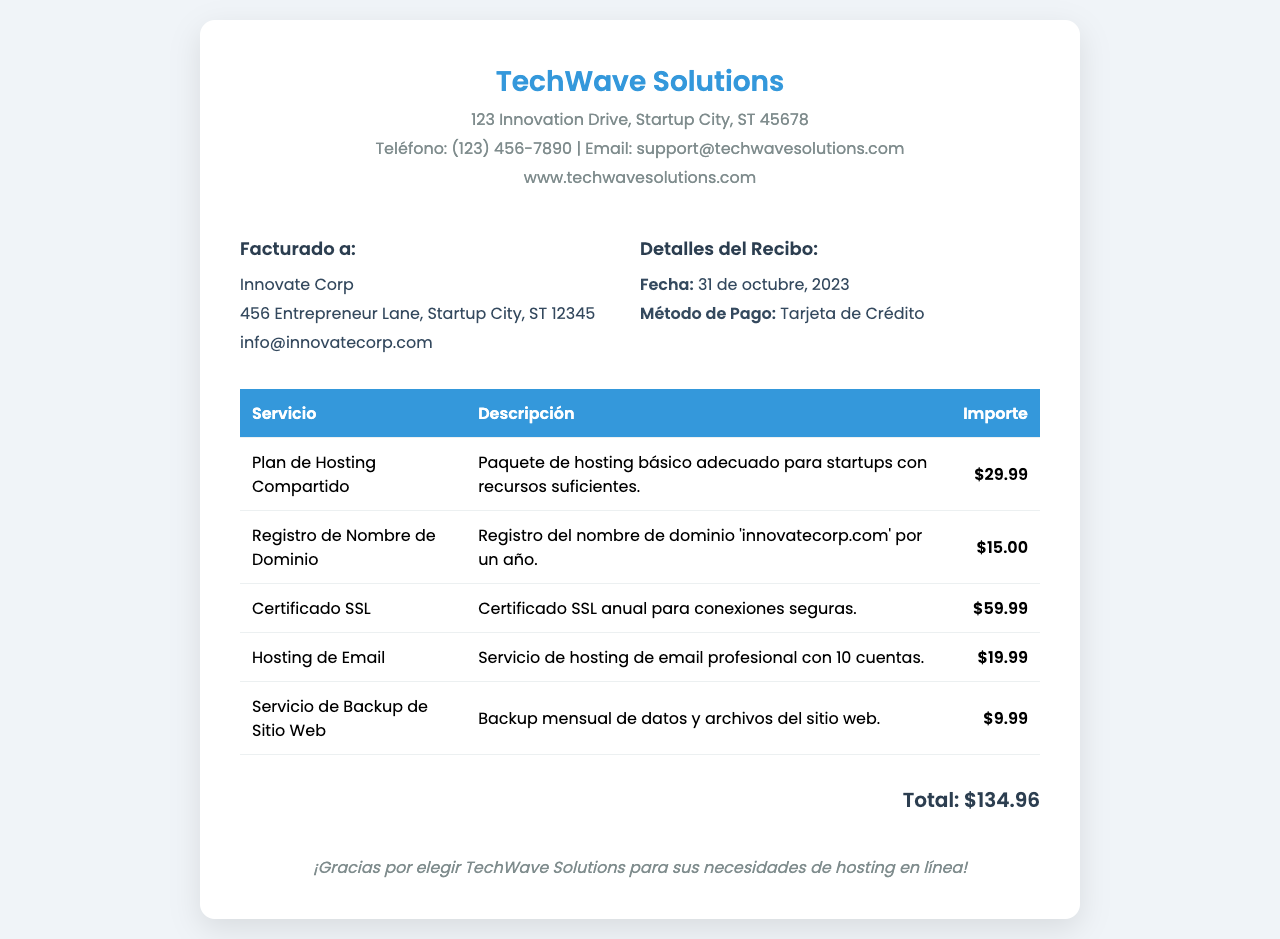¿Qué empresa emitió el recibo? La empresa que emitió el recibo es TechWave Solutions, que se menciona en la parte superior del documento.
Answer: TechWave Solutions ¿Cuándo fue la fecha de emisión del recibo? La fecha de emisión está indicada en los detalles del recibo y es el 31 de octubre, 2023.
Answer: 31 de octubre, 2023 ¿Cuál es el importe total a pagar? El total a pagar se muestra en la sección de total al final del documento, que suma todos los cargos.
Answer: $134.96 ¿Qué servicio tiene un costo de $15.00? Se debe buscar el servicio específico que corresponde a este importe en la tabla de servicios.
Answer: Registro de Nombre de Dominio ¿Cuántas cuentas de email están incluidas en el servicio de Hosting de Email? El número de cuentas está indicado en la descripción del servicio de Hosting de Email.
Answer: 10 ¿Cuál es el método de pago utilizado para este recibo? El método de pago se menciona en los detalles del recibo.
Answer: Tarjeta de Crédito ¿Cuál es el nombre del dominio registrado? El nombre del dominio se especifica en la descripción del servicio de Registro de Nombre de Dominio.
Answer: innovatecorp.com ¿Qué incluye el servicio de Backup de Sitio Web? El contenido del servicio se describe en la línea correspondiente de la tabla.
Answer: Backup mensual de datos y archivos ¿Hay un certificado de seguridad incluido en la factura? La presencia de un certificado se menciona en la lista de servicios con su respectivo costo.
Answer: Sí 